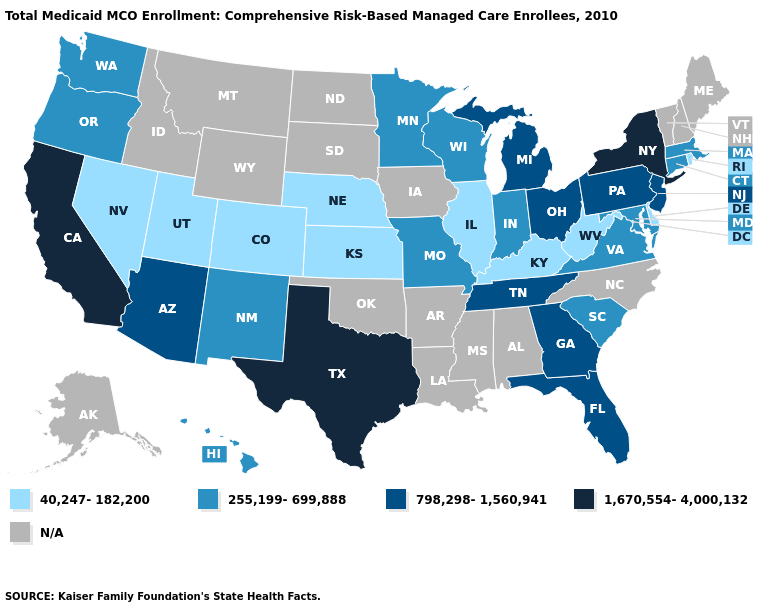Name the states that have a value in the range 255,199-699,888?
Write a very short answer. Connecticut, Hawaii, Indiana, Maryland, Massachusetts, Minnesota, Missouri, New Mexico, Oregon, South Carolina, Virginia, Washington, Wisconsin. What is the value of Hawaii?
Short answer required. 255,199-699,888. Does the first symbol in the legend represent the smallest category?
Answer briefly. Yes. What is the value of Virginia?
Keep it brief. 255,199-699,888. Among the states that border Mississippi , which have the lowest value?
Be succinct. Tennessee. Which states have the lowest value in the USA?
Quick response, please. Colorado, Delaware, Illinois, Kansas, Kentucky, Nebraska, Nevada, Rhode Island, Utah, West Virginia. What is the value of New Hampshire?
Be succinct. N/A. Name the states that have a value in the range 798,298-1,560,941?
Quick response, please. Arizona, Florida, Georgia, Michigan, New Jersey, Ohio, Pennsylvania, Tennessee. What is the value of South Carolina?
Answer briefly. 255,199-699,888. What is the value of Washington?
Concise answer only. 255,199-699,888. Name the states that have a value in the range 40,247-182,200?
Answer briefly. Colorado, Delaware, Illinois, Kansas, Kentucky, Nebraska, Nevada, Rhode Island, Utah, West Virginia. What is the lowest value in states that border Illinois?
Write a very short answer. 40,247-182,200. Which states have the lowest value in the USA?
Give a very brief answer. Colorado, Delaware, Illinois, Kansas, Kentucky, Nebraska, Nevada, Rhode Island, Utah, West Virginia. Name the states that have a value in the range 255,199-699,888?
Short answer required. Connecticut, Hawaii, Indiana, Maryland, Massachusetts, Minnesota, Missouri, New Mexico, Oregon, South Carolina, Virginia, Washington, Wisconsin. What is the value of Minnesota?
Be succinct. 255,199-699,888. 